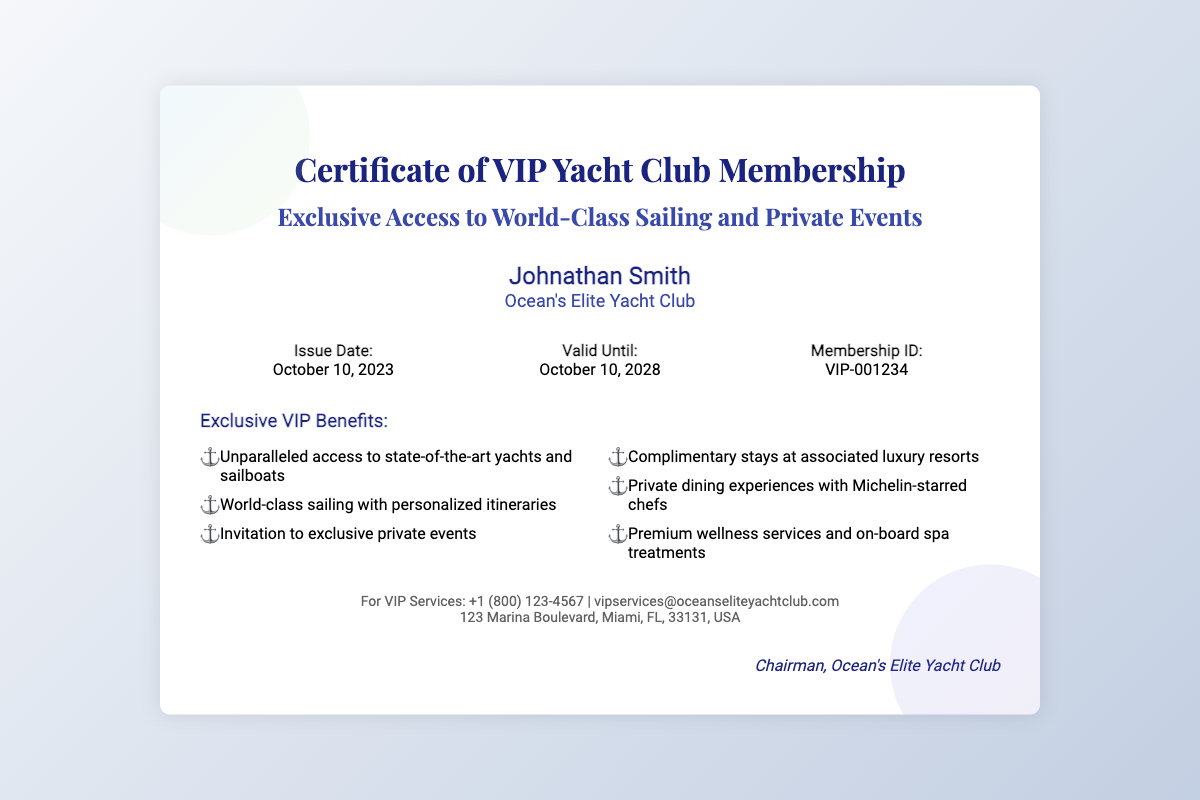What is the membership ID? The membership ID is located in the details section of the certificate.
Answer: VIP-001234 Who is the member? The member's name is stated prominently at the top of the document.
Answer: Johnathan Smith What is the issue date of the certificate? The issue date is listed in the details section of the document.
Answer: October 10, 2023 What is the valid until date? The valid until date is found in the details section as well.
Answer: October 10, 2028 What club is mentioned in the certificate? The club name appears in the member info section of the certificate.
Answer: Ocean's Elite Yacht Club How many exclusive VIP benefits are listed? Counting the items in the benefits section provides the answer.
Answer: Six What type of events are members invited to? The type of events is specified under the exclusive benefits heading.
Answer: Exclusive private events What is the contact email for VIP services? The contact email is provided at the bottom of the document.
Answer: vipservices@oceanseliteyachtclub.com Who signed the certificate? The signature at the bottom of the document indicates the signer.
Answer: Chairman, Ocean's Elite Yacht Club 